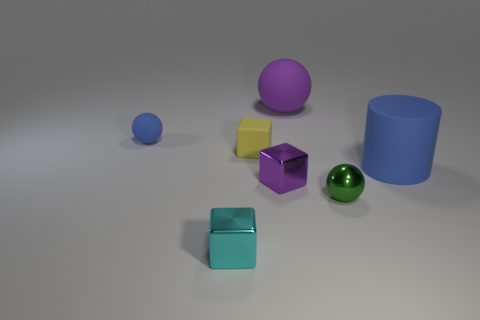Are there any metal cubes?
Your response must be concise. Yes. How many things are things that are on the left side of the tiny cyan cube or small yellow metallic objects?
Your response must be concise. 1. Does the cylinder have the same color as the sphere on the left side of the tiny yellow thing?
Your answer should be very brief. Yes. Are there any purple rubber spheres of the same size as the green metallic ball?
Give a very brief answer. No. There is a purple thing that is to the left of the big rubber object that is left of the tiny metal ball; what is its material?
Provide a succinct answer. Metal. How many matte blocks are the same color as the large matte ball?
Offer a terse response. 0. There is a small cyan thing that is made of the same material as the tiny purple thing; what shape is it?
Offer a terse response. Cube. What is the size of the shiny cube that is behind the small green metal sphere?
Your response must be concise. Small. Are there an equal number of small blue matte spheres in front of the small yellow rubber block and metal spheres that are right of the large cylinder?
Your response must be concise. Yes. There is a sphere that is to the right of the purple object behind the blue thing that is right of the matte cube; what is its color?
Ensure brevity in your answer.  Green. 